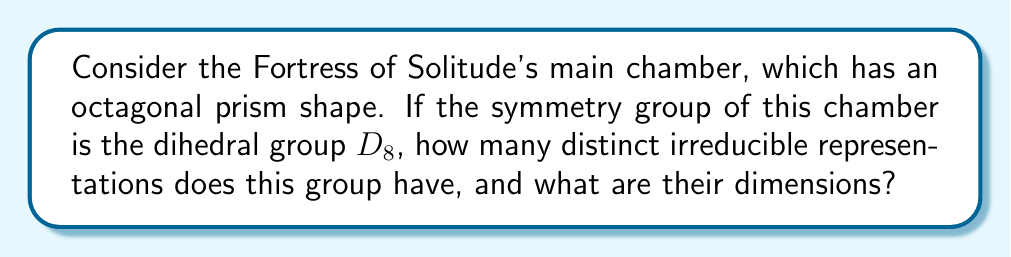Show me your answer to this math problem. To analyze the irreducible representations of the Fortress of Solitude's geometric design, we'll follow these steps:

1) The dihedral group $D_8$ has order 16, as it consists of 8 rotations and 8 reflections.

2) For any finite group $G$, the number of irreducible representations is equal to the number of conjugacy classes in $G$.

3) Let's determine the conjugacy classes of $D_8$:
   - Identity element: {$e$}
   - Rotation by 180°: {$r^4$}
   - Rotations by 90° and 270°: {$r^2, r^6$}
   - Rotations by 45°, 135°, 225°, 315°: {$r, r^3, r^5, r^7$}
   - Reflections through vertices: {$s, sr^2, sr^4, sr^6$}
   - Reflections through edges: {$sr, sr^3, sr^5, sr^7$}

   There are 5 conjugacy classes in total.

4) Therefore, $D_8$ has 5 irreducible representations.

5) To determine their dimensions, we use the fact that for a finite group $G$:

   $$\sum_{i=1}^k n_i^2 = |G|$$

   where $k$ is the number of irreducible representations and $n_i$ are their dimensions.

6) For $D_8$, we know that there are always two 1-dimensional representations for dihedral groups (the trivial representation and the sign representation).

7) Let the remaining dimensions be $a$, $b$, and $c$. We can set up the equation:

   $$1^2 + 1^2 + a^2 + b^2 + c^2 = 16$$

8) The only integer solution satisfying this equation is $a = b = c = 2$.

Therefore, $D_8$ has two 1-dimensional representations and three 2-dimensional representations.
Answer: 5 irreducible representations: two 1-dimensional and three 2-dimensional 